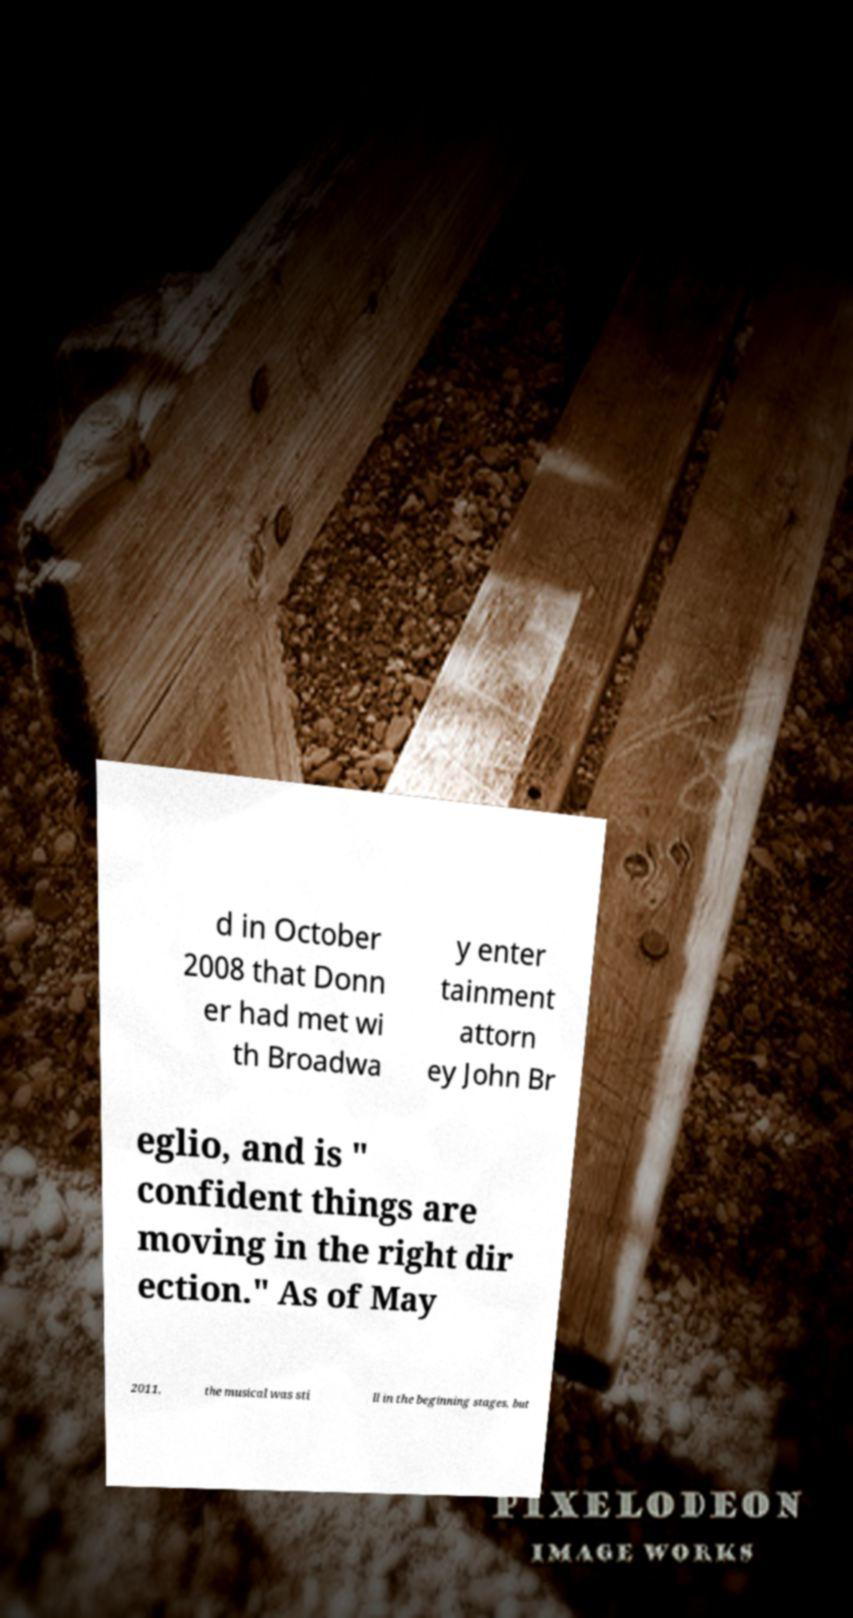Can you accurately transcribe the text from the provided image for me? d in October 2008 that Donn er had met wi th Broadwa y enter tainment attorn ey John Br eglio, and is " confident things are moving in the right dir ection." As of May 2011, the musical was sti ll in the beginning stages, but 